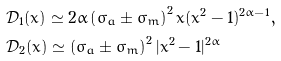<formula> <loc_0><loc_0><loc_500><loc_500>& \mathcal { D } _ { 1 } ( x ) \simeq 2 \alpha \left ( \sigma _ { a } \pm \sigma _ { m } \right ) ^ { 2 } x ( x ^ { 2 } - 1 ) ^ { 2 \alpha - 1 } , \\ & \mathcal { D } _ { 2 } ( x ) \simeq \left ( \sigma _ { a } \pm \sigma _ { m } \right ) ^ { 2 } | x ^ { 2 } - 1 | ^ { 2 \alpha }</formula> 